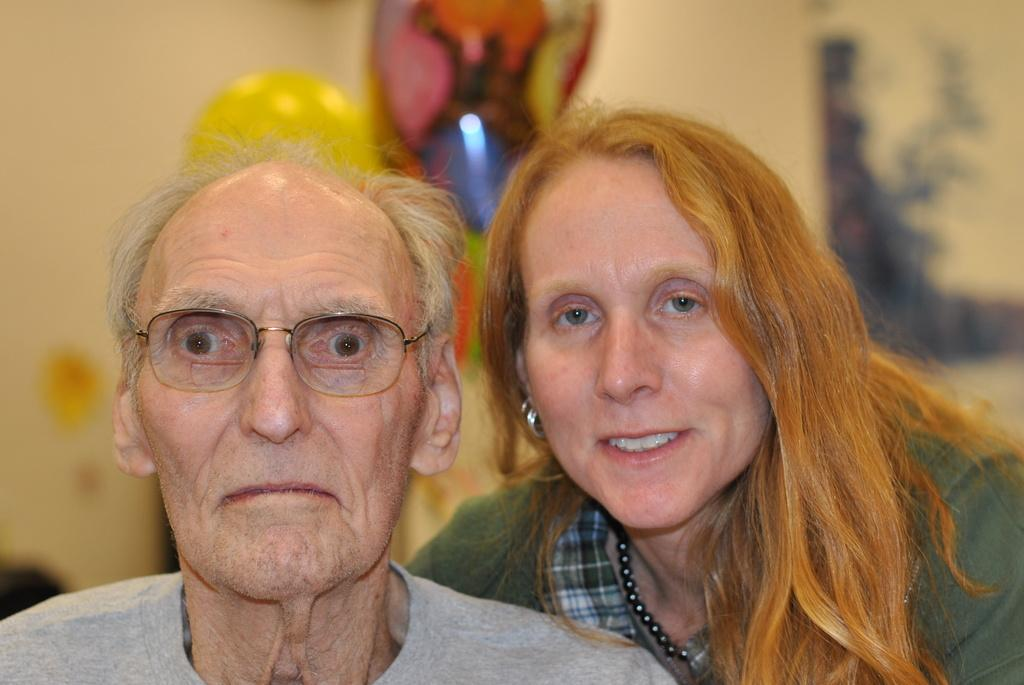How many people are in the image? There are two people in the image. What colors are the dresses of the two people? One person is wearing an ash-colored dress, and the other person is wearing a green-colored dress. What can be seen behind the people in the image? The background of the image is a cream-colored wall, and it is blurred. What type of ticket is the person holding in the image? There is no ticket visible in the image. What flight are the people waiting for in the image? There is no indication of a flight or any travel-related context in the image. 